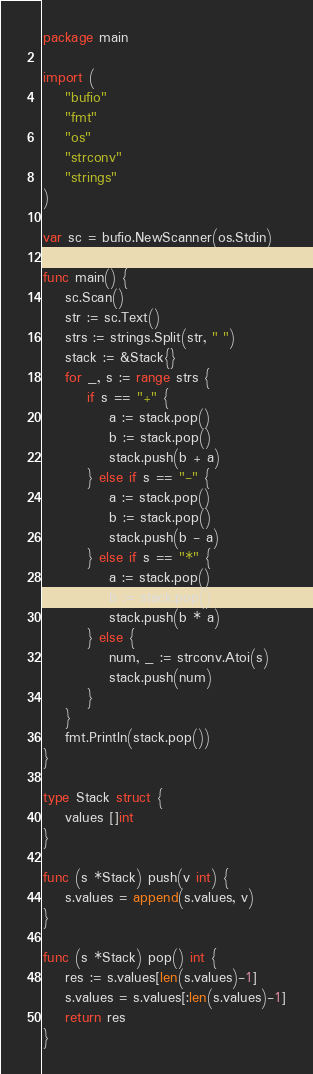Convert code to text. <code><loc_0><loc_0><loc_500><loc_500><_Go_>package main

import (
	"bufio"
	"fmt"
	"os"
	"strconv"
	"strings"
)

var sc = bufio.NewScanner(os.Stdin)

func main() {
	sc.Scan()
	str := sc.Text()
	strs := strings.Split(str, " ")
	stack := &Stack{}
	for _, s := range strs {
		if s == "+" {
			a := stack.pop()
			b := stack.pop()
			stack.push(b + a)
		} else if s == "-" {
			a := stack.pop()
			b := stack.pop()
			stack.push(b - a)
		} else if s == "*" {
			a := stack.pop()
			b := stack.pop()
			stack.push(b * a)
		} else {
			num, _ := strconv.Atoi(s)
			stack.push(num)
		}
	}
	fmt.Println(stack.pop())
}

type Stack struct {
	values []int
}

func (s *Stack) push(v int) {
	s.values = append(s.values, v)
}

func (s *Stack) pop() int {
	res := s.values[len(s.values)-1]
	s.values = s.values[:len(s.values)-1]
	return res
}

</code> 